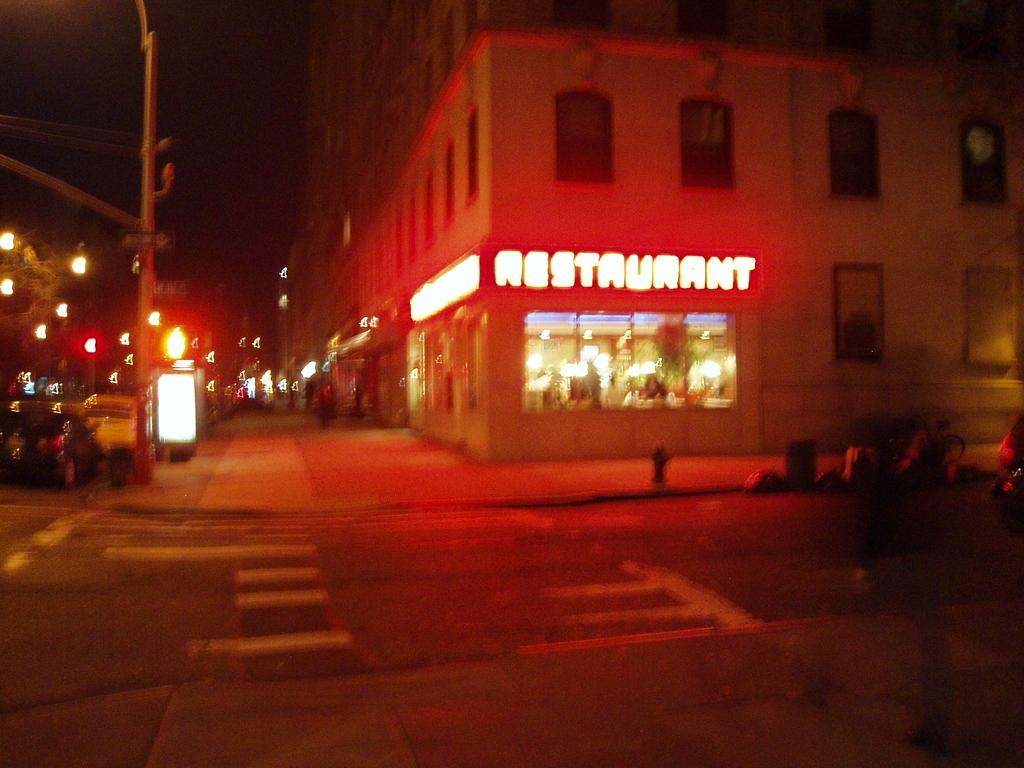What type of structures are visible in the image? There are buildings with walls and windows in the image. What can be seen on the road in the image? There are vehicles on the road in the image. What is the tall, vertical object in the image? There is a pole in the image. What are the signs that provide information or directions in the image? There are sign boards in the image. What type of establishment can be found in the image? There is a store in the image. Can you see any marks on the vehicles in the image? There is no mention of marks on the vehicles in the image, so we cannot determine their presence. Are there any mittens visible in the image? There are no mittens present in the image. 